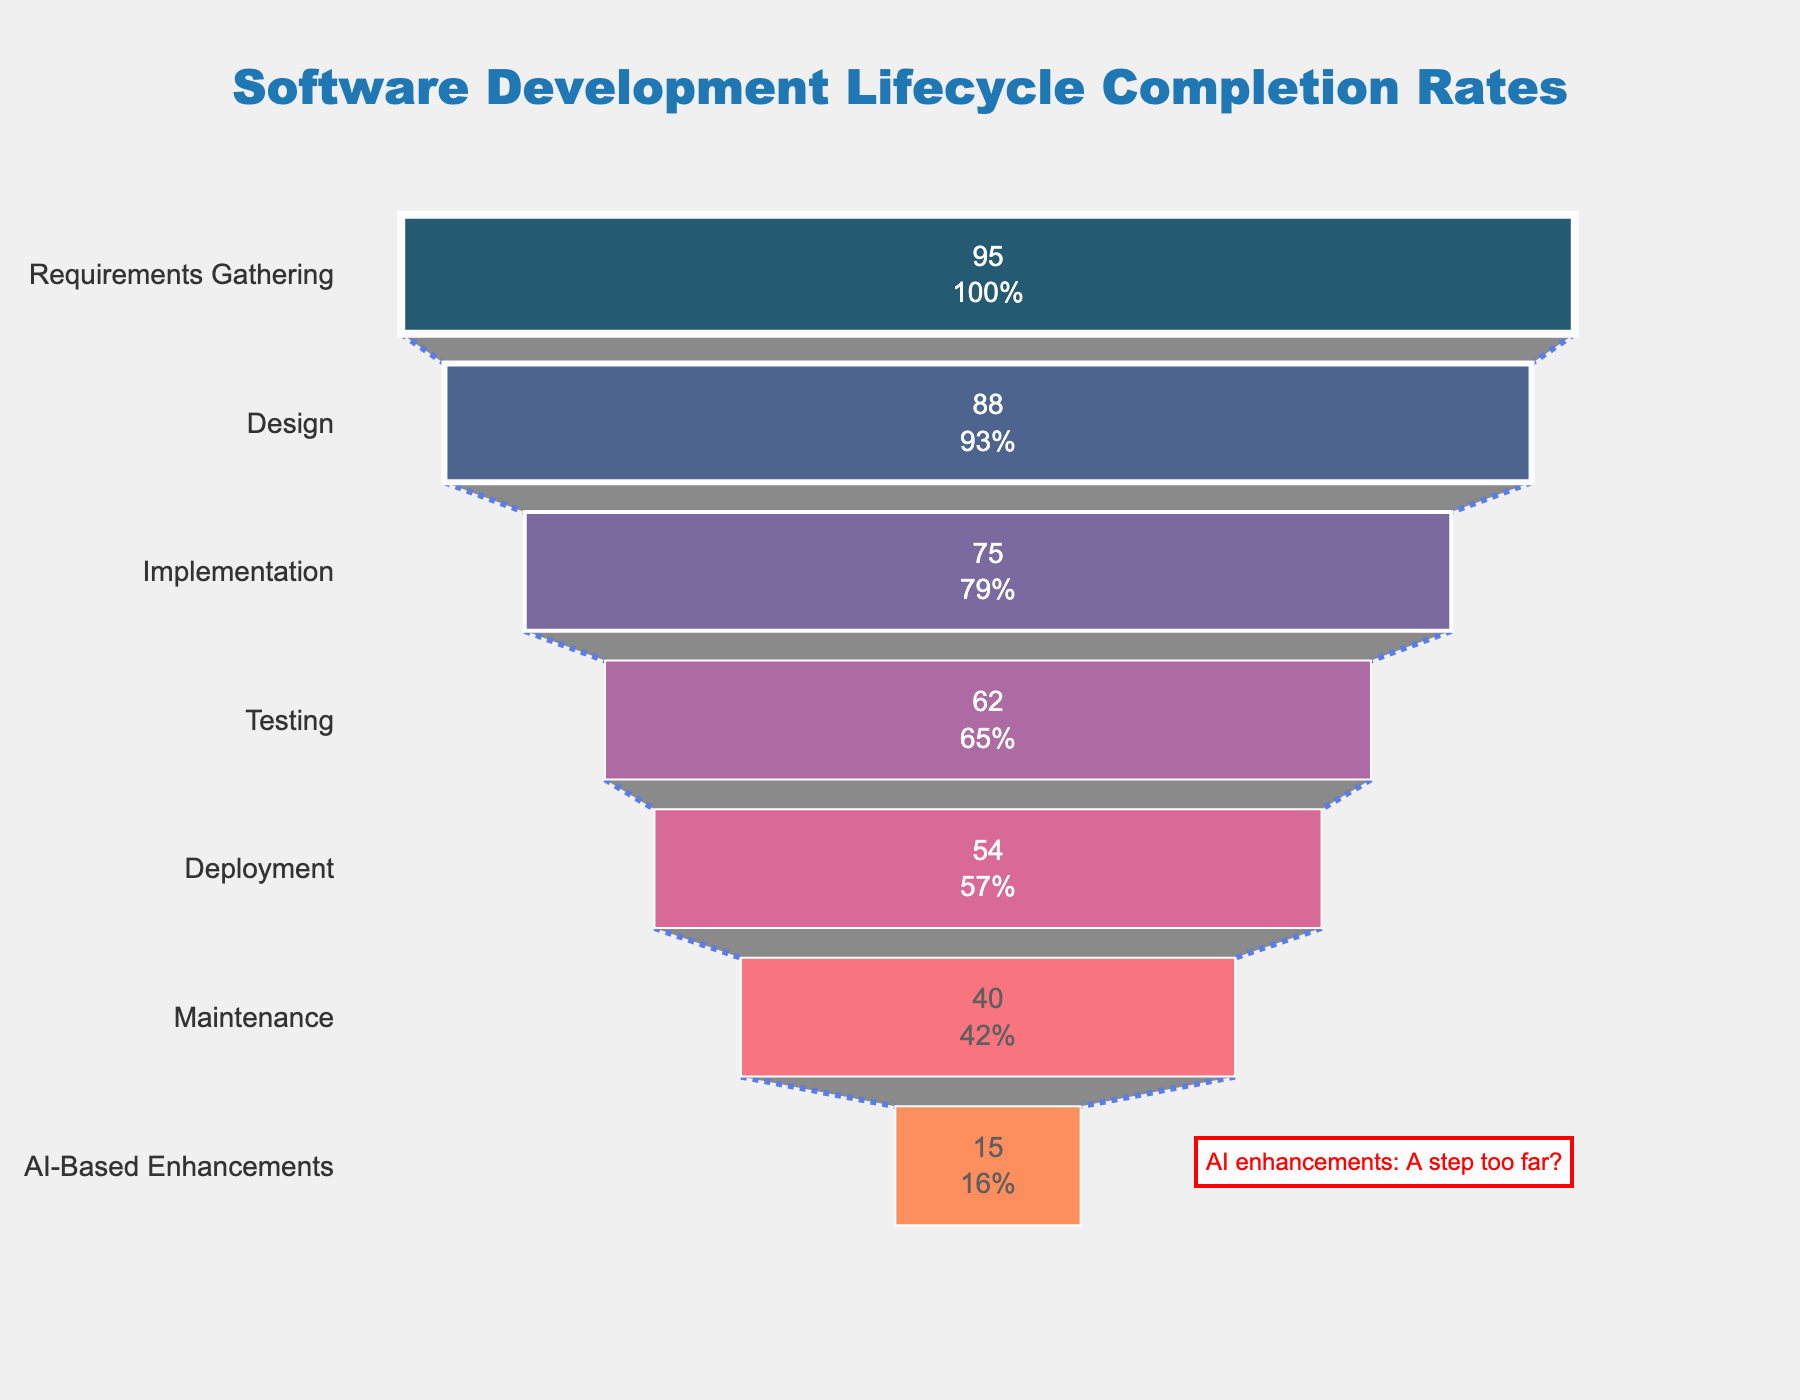What's the title of the funnel chart? The title is usually at the top of the chart and is meant to describe the content. In this figure, the title is clearly shown at the top center.
Answer: Software Development Lifecycle Completion Rates How many stages are there in total? Count the number of distinct stages listed on the Y-axis of the funnel chart.
Answer: 7 What is the completion rate for the Design stage? Locate the Design stage on the Y-axis and identify the corresponding value on the X-axis.
Answer: 88% Which stage has the lowest completion rate? Compare the completion rates for all stages and identify the smallest number.
Answer: AI-Based Enhancements What's the difference in completion rates between Testing and Deployment? Locate the Testing and Deployment stages, note their completion rates, and subtract the Deployment rate from the Testing rate. 62% - 54% = 8%
Answer: 8% What is the combined completion rate of Requirements Gathering and Implementation? Add the completion rates for Requirements Gathering (95%) and Implementation (75%). 95% + 75% = 170%
Answer: 170% Is the completion rate for Maintenance more than twice that of AI-Based Enhancements? Compare the Maintenance (40%) and AI-Based Enhancements (15%) rates. Check if 40% is more than twice 15% (i.e., 30%).
Answer: Yes Which stage shows the most significant drop in completion rate compared to the previous stage? Calculate the differences between consecutive stages’ completion rates and find the largest drop. 88%-75%, 75%-62%, 62%-54%, etc. The largest difference is between Deployment and Maintenance. 40% - 54% = 14%
Answer: Maintenance What percentage of the initial value does the Testing stage represent? The funnel chart shows each stage as a percentage of the initial value. Identify the Testing stage and its percentage representation.
Answer: 62% What's the difference in completion rates between the first and last stages? Subtract the completion rate of the last stage (AI-Based Enhancements 15%) from the first stage (Requirements Gathering 95%). 95% - 15% = 80%
Answer: 80% 